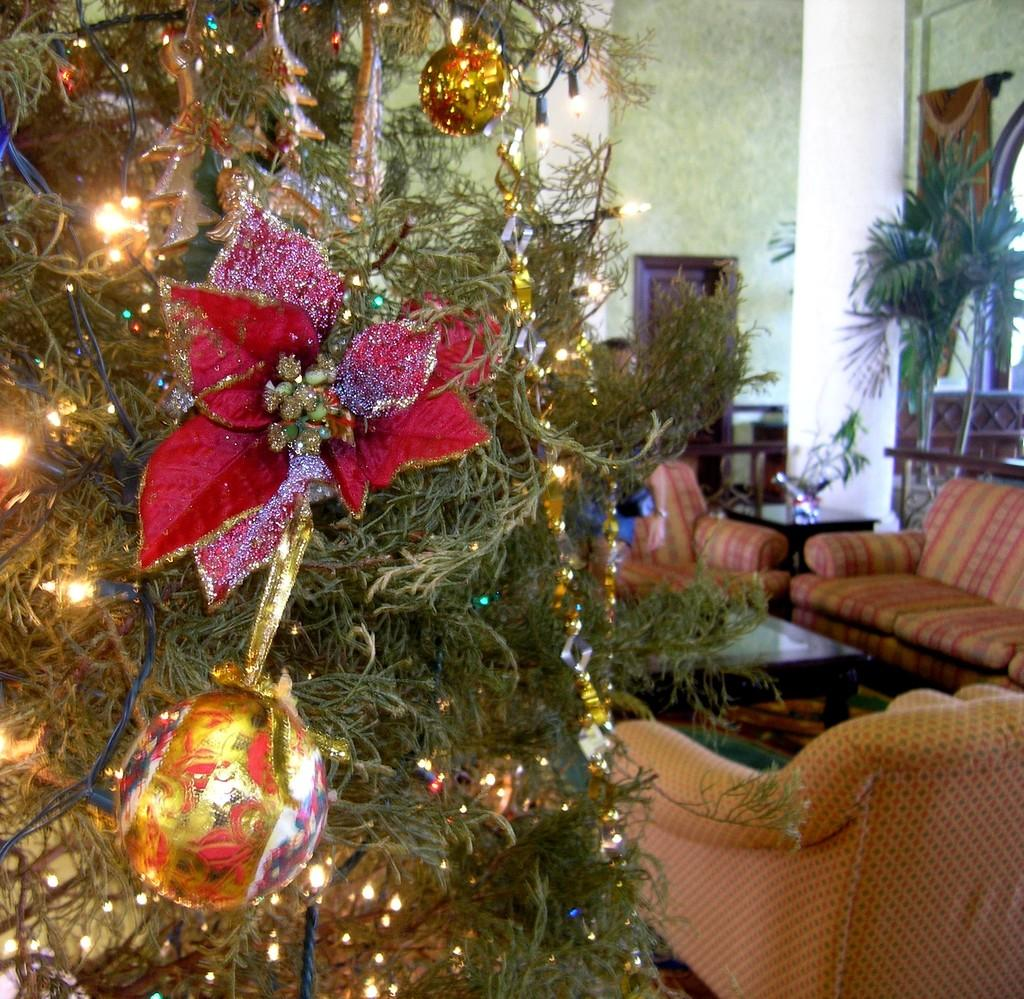What is located on the left side of the image? There is a Christmas tree on the left side of the image. What can be seen on the right side of the image? There is a sofa set on the right side of the image. What type of vegetation is behind the sofa set? There are plants behind the sofa set. What architectural feature is visible in the background of the image? There is a door on the wall in the background of the image. What type of clam can be seen on the sofa in the image? There is no clam present in the image; it features a Christmas tree, a sofa set, plants, and a door. What is the aftermath of the event that took place in the image? There is no event depicted in the image, so it is not possible to determine the aftermath. 